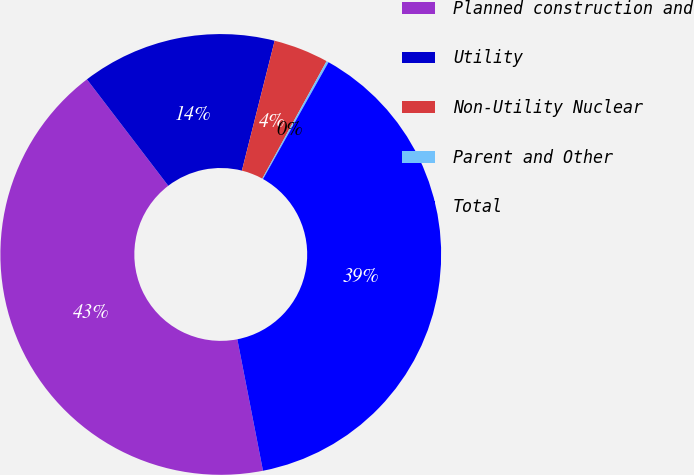<chart> <loc_0><loc_0><loc_500><loc_500><pie_chart><fcel>Planned construction and<fcel>Utility<fcel>Non-Utility Nuclear<fcel>Parent and Other<fcel>Total<nl><fcel>42.68%<fcel>14.32%<fcel>4.04%<fcel>0.16%<fcel>38.8%<nl></chart> 